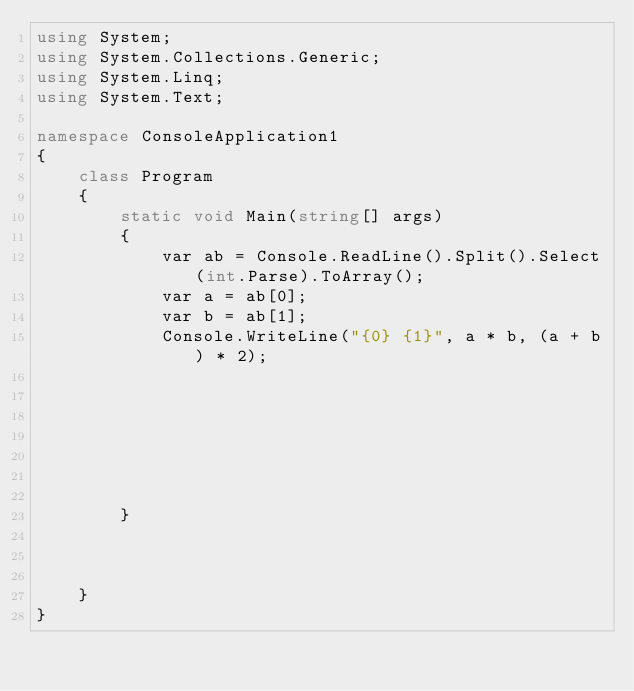<code> <loc_0><loc_0><loc_500><loc_500><_C#_>using System;
using System.Collections.Generic;
using System.Linq;
using System.Text;

namespace ConsoleApplication1
{
    class Program
    {
        static void Main(string[] args)
        {
            var ab = Console.ReadLine().Split().Select(int.Parse).ToArray();
            var a = ab[0];
            var b = ab[1];
            Console.WriteLine("{0} {1}", a * b, (a + b) * 2);
           






        }
                
                
                
    }
}</code> 